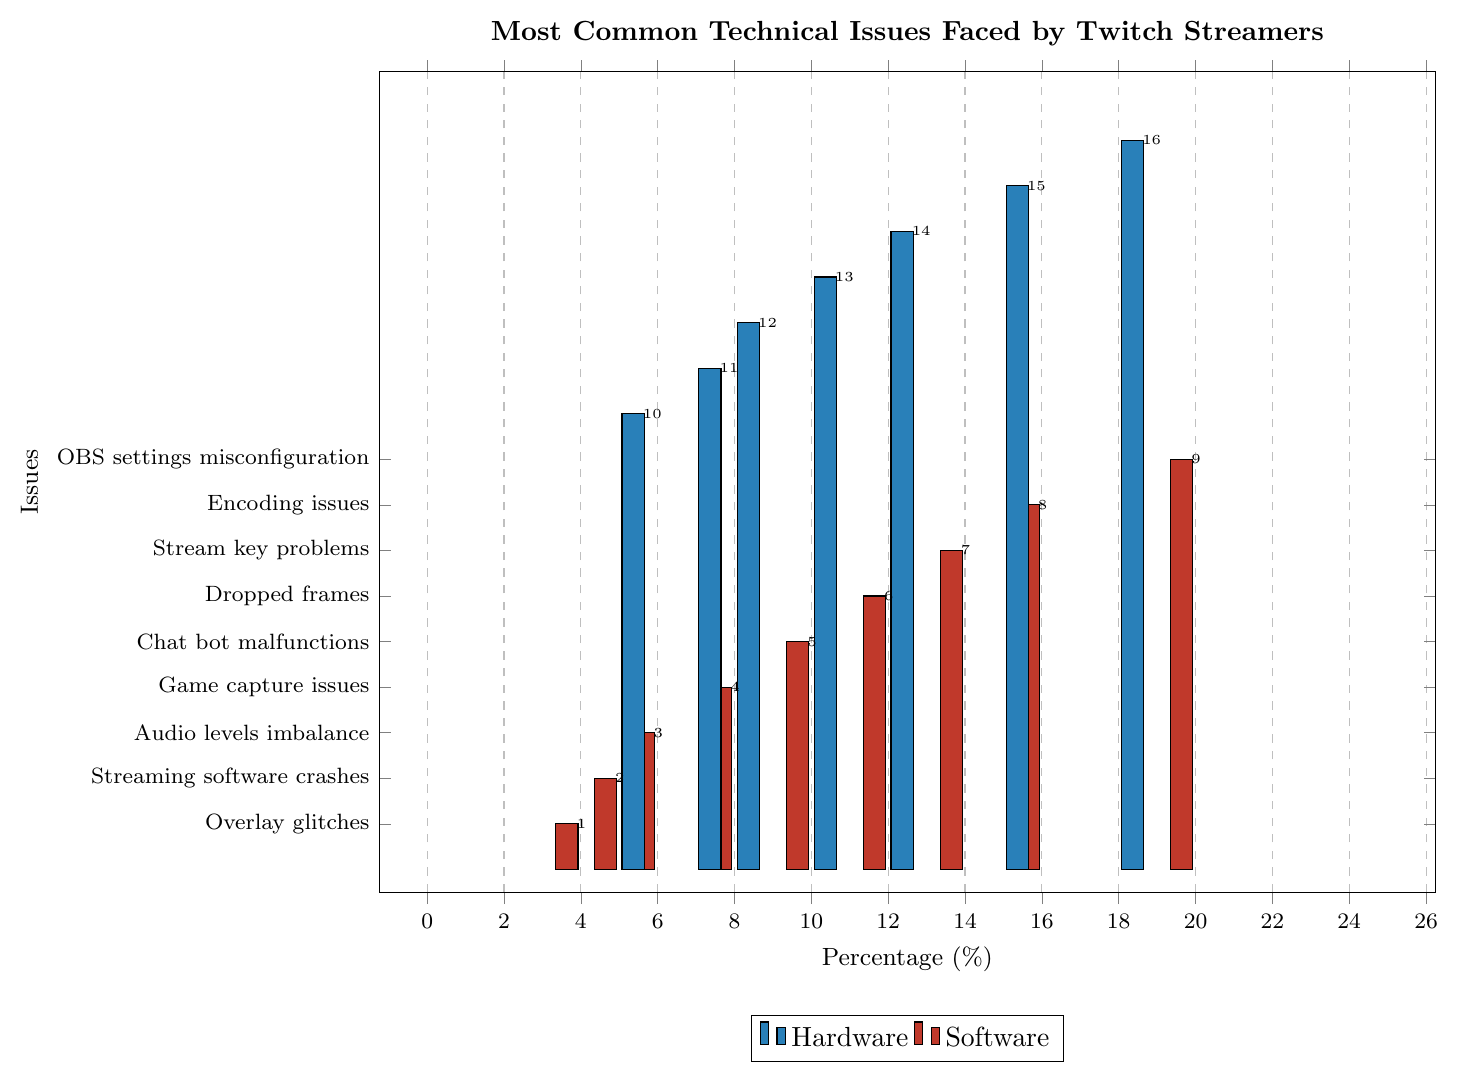Which category has the highest percentage issue? To determine the category with the highest percentage issue, look for the longest bar in the chart. The highest percentage issue is "OBS settings misconfiguration" under the software category, at 20%.
Answer: Software Between 'Webcam not detected' and 'Stream key problems', which issue is more common? Compare the lengths of the bars corresponding to 'Webcam not detected' and 'Stream key problems'. 'Webcam not detected' has 15% while 'Stream key problems' has 14%, thus 'Webcam not detected' is more common.
Answer: Webcam not detected What is the combined percentage of 'Dropped frames' and 'Microphone not working'? Find the percentage values for both 'Dropped frames' (12%) and 'Microphone not working' (12%). Adding them together gives 12% + 12% = 24%.
Answer: 24% Is 'Poor video quality' less common than 'Encoding issues'? Compare the lengths of the bars for 'Poor video quality' and 'Encoding issues'. 'Poor video quality' has a percentage of 10%, while 'Encoding issues' is at 16%, indicating that 'Poor video quality' is indeed less common.
Answer: Yes Which issue is more prevalent - 'Overheating PC' or 'Chat bot malfunctions'? Compare the heights of the bars denoting 'Overheating PC' and 'Chat bot malfunctions'. 'Overheating PC' shows 8% while 'Chat bot malfunctions' has 10%. 'Chat bot malfunctions' is more prevalent.
Answer: Chat bot malfunctions What percentage of technical issues are attributed to 'Capture card failure' and 'Audio desync' together? Find and sum the percentages for 'Capture card failure' (5%) and 'Audio desync' (18%). The combined percentage is 5% + 18% = 23%.
Answer: 23% Order the following issues by frequency from least to most: 'Game capture issues', 'Streaming software crashes', 'Overlay glitches'. Checking the respective percentages, 'Overlay glitches' (4%), 'Streaming software crashes' (5%), 'Game capture issues' (8%). Arranging them in order: Overlay glitches, Streaming software crashes, Game capture issues.
Answer: Overlay glitches, Streaming software crashes, Game capture issues How much higher is the percentage of 'OBS settings misconfiguration' compared to 'Audio levels imbalance'? The percentage for 'OBS settings misconfiguration' is 20%, and for 'Audio levels imbalance' it is 6%. The difference is 20% - 6% = 14%.
Answer: 14% If you add the percentages of hardware issues ('Audio desync', 'Webcam not detected', 'Microphone not working') together, what is their total? Find and sum the given hardware issues: Audio desync (18%), Webcam not detected (15%), and Microphone not working (12%). Total = 18% + 15% + 12% = 45%.
Answer: 45% 